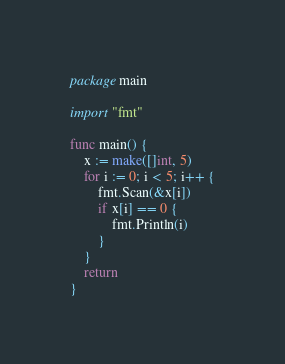Convert code to text. <code><loc_0><loc_0><loc_500><loc_500><_Go_>package main

import "fmt"

func main() {
	x := make([]int, 5)
	for i := 0; i < 5; i++ {
		fmt.Scan(&x[i])
		if x[i] == 0 {
			fmt.Println(i)
		}
	}
	return
}
</code> 